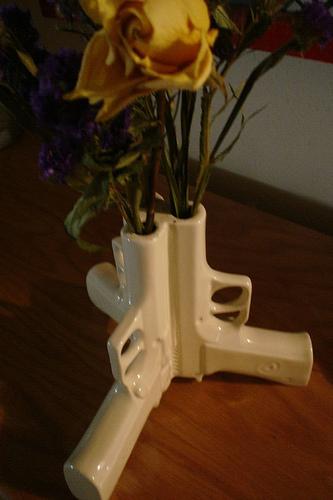What's in the vase?
Quick response, please. Flowers. What item does the vase resemble?
Quick response, please. Gun. What color are the flowers?
Quick response, please. Yellow. 